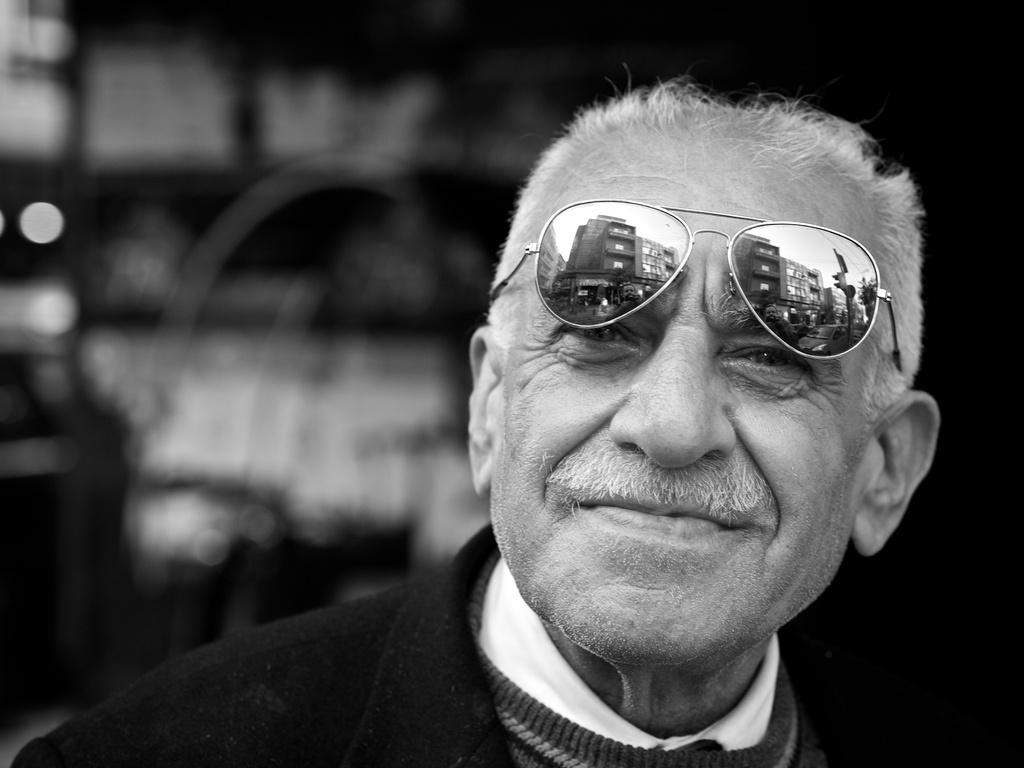What is the color scheme of the image? The image is black and white. How would you describe the background of the image? The background of the image is blurred. Who is the main subject in the image? There is a man in the middle of the image. What is the man's facial expression? The man has a smiling face. What is the man wearing on his face? The man is wearing goggles. What type of guide is the man holding in the image? There is no guide present in the image; the man is wearing goggles. What is causing the man to feel shame in the image? There is no indication of shame in the image; the man has a smiling face. 